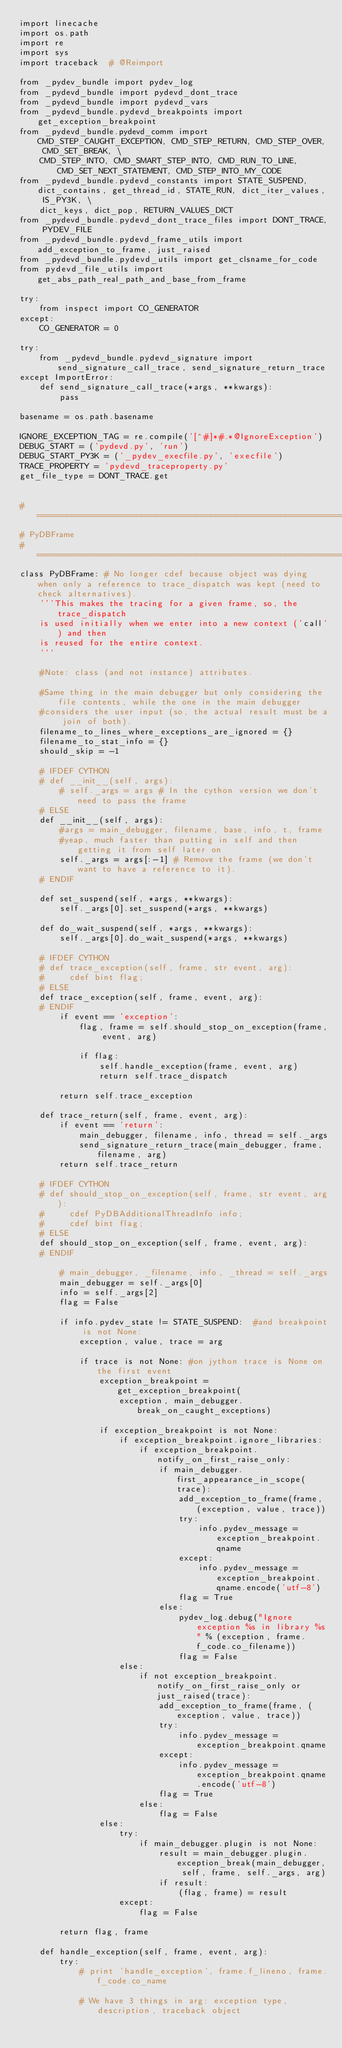<code> <loc_0><loc_0><loc_500><loc_500><_Python_>import linecache
import os.path
import re
import sys
import traceback  # @Reimport

from _pydev_bundle import pydev_log
from _pydevd_bundle import pydevd_dont_trace
from _pydevd_bundle import pydevd_vars
from _pydevd_bundle.pydevd_breakpoints import get_exception_breakpoint
from _pydevd_bundle.pydevd_comm import CMD_STEP_CAUGHT_EXCEPTION, CMD_STEP_RETURN, CMD_STEP_OVER, CMD_SET_BREAK, \
    CMD_STEP_INTO, CMD_SMART_STEP_INTO, CMD_RUN_TO_LINE, CMD_SET_NEXT_STATEMENT, CMD_STEP_INTO_MY_CODE
from _pydevd_bundle.pydevd_constants import STATE_SUSPEND, dict_contains, get_thread_id, STATE_RUN, dict_iter_values, IS_PY3K, \
    dict_keys, dict_pop, RETURN_VALUES_DICT
from _pydevd_bundle.pydevd_dont_trace_files import DONT_TRACE, PYDEV_FILE
from _pydevd_bundle.pydevd_frame_utils import add_exception_to_frame, just_raised
from _pydevd_bundle.pydevd_utils import get_clsname_for_code
from pydevd_file_utils import get_abs_path_real_path_and_base_from_frame

try:
    from inspect import CO_GENERATOR
except:
    CO_GENERATOR = 0

try:
    from _pydevd_bundle.pydevd_signature import send_signature_call_trace, send_signature_return_trace
except ImportError:
    def send_signature_call_trace(*args, **kwargs):
        pass

basename = os.path.basename

IGNORE_EXCEPTION_TAG = re.compile('[^#]*#.*@IgnoreException')
DEBUG_START = ('pydevd.py', 'run')
DEBUG_START_PY3K = ('_pydev_execfile.py', 'execfile')
TRACE_PROPERTY = 'pydevd_traceproperty.py'
get_file_type = DONT_TRACE.get


#=======================================================================================================================
# PyDBFrame
#=======================================================================================================================
class PyDBFrame: # No longer cdef because object was dying when only a reference to trace_dispatch was kept (need to check alternatives).
    '''This makes the tracing for a given frame, so, the trace_dispatch
    is used initially when we enter into a new context ('call') and then
    is reused for the entire context.
    '''

    #Note: class (and not instance) attributes.

    #Same thing in the main debugger but only considering the file contents, while the one in the main debugger
    #considers the user input (so, the actual result must be a join of both).
    filename_to_lines_where_exceptions_are_ignored = {}
    filename_to_stat_info = {}
    should_skip = -1

    # IFDEF CYTHON
    # def __init__(self, args):
        # self._args = args # In the cython version we don't need to pass the frame
    # ELSE
    def __init__(self, args):
        #args = main_debugger, filename, base, info, t, frame
        #yeap, much faster than putting in self and then getting it from self later on
        self._args = args[:-1] # Remove the frame (we don't want to have a reference to it).
    # ENDIF

    def set_suspend(self, *args, **kwargs):
        self._args[0].set_suspend(*args, **kwargs)

    def do_wait_suspend(self, *args, **kwargs):
        self._args[0].do_wait_suspend(*args, **kwargs)

    # IFDEF CYTHON
    # def trace_exception(self, frame, str event, arg):
    #     cdef bint flag;
    # ELSE
    def trace_exception(self, frame, event, arg):
    # ENDIF
        if event == 'exception':
            flag, frame = self.should_stop_on_exception(frame, event, arg)

            if flag:
                self.handle_exception(frame, event, arg)
                return self.trace_dispatch

        return self.trace_exception

    def trace_return(self, frame, event, arg):
        if event == 'return':
            main_debugger, filename, info, thread = self._args
            send_signature_return_trace(main_debugger, frame, filename, arg)
        return self.trace_return

    # IFDEF CYTHON
    # def should_stop_on_exception(self, frame, str event, arg):
    #     cdef PyDBAdditionalThreadInfo info;
    #     cdef bint flag;
    # ELSE
    def should_stop_on_exception(self, frame, event, arg):
    # ENDIF

        # main_debugger, _filename, info, _thread = self._args
        main_debugger = self._args[0]
        info = self._args[2]
        flag = False

        if info.pydev_state != STATE_SUSPEND:  #and breakpoint is not None:
            exception, value, trace = arg

            if trace is not None: #on jython trace is None on the first event
                exception_breakpoint = get_exception_breakpoint(
                    exception, main_debugger.break_on_caught_exceptions)

                if exception_breakpoint is not None:
                    if exception_breakpoint.ignore_libraries:
                        if exception_breakpoint.notify_on_first_raise_only:
                            if main_debugger.first_appearance_in_scope(trace):
                                add_exception_to_frame(frame, (exception, value, trace))
                                try:
                                    info.pydev_message = exception_breakpoint.qname
                                except:
                                    info.pydev_message = exception_breakpoint.qname.encode('utf-8')
                                flag = True
                            else:
                                pydev_log.debug("Ignore exception %s in library %s" % (exception, frame.f_code.co_filename))
                                flag = False
                    else:
                        if not exception_breakpoint.notify_on_first_raise_only or just_raised(trace):
                            add_exception_to_frame(frame, (exception, value, trace))
                            try:
                                info.pydev_message = exception_breakpoint.qname
                            except:
                                info.pydev_message = exception_breakpoint.qname.encode('utf-8')
                            flag = True
                        else:
                            flag = False
                else:
                    try:
                        if main_debugger.plugin is not None:
                            result = main_debugger.plugin.exception_break(main_debugger, self, frame, self._args, arg)
                            if result:
                                (flag, frame) = result
                    except:
                        flag = False

        return flag, frame

    def handle_exception(self, frame, event, arg):
        try:
            # print 'handle_exception', frame.f_lineno, frame.f_code.co_name

            # We have 3 things in arg: exception type, description, traceback object</code> 